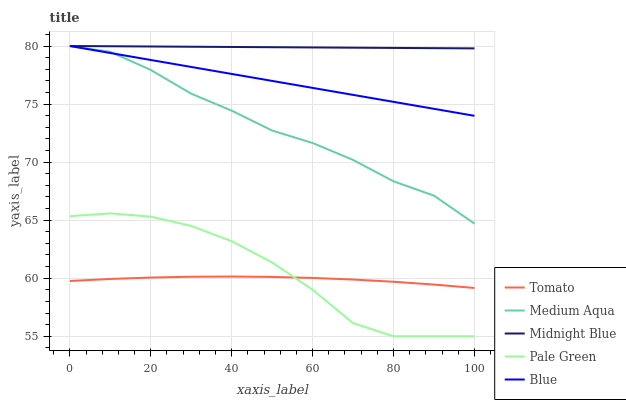Does Tomato have the minimum area under the curve?
Answer yes or no. Yes. Does Midnight Blue have the maximum area under the curve?
Answer yes or no. Yes. Does Blue have the minimum area under the curve?
Answer yes or no. No. Does Blue have the maximum area under the curve?
Answer yes or no. No. Is Midnight Blue the smoothest?
Answer yes or no. Yes. Is Pale Green the roughest?
Answer yes or no. Yes. Is Blue the smoothest?
Answer yes or no. No. Is Blue the roughest?
Answer yes or no. No. Does Pale Green have the lowest value?
Answer yes or no. Yes. Does Blue have the lowest value?
Answer yes or no. No. Does Midnight Blue have the highest value?
Answer yes or no. Yes. Does Pale Green have the highest value?
Answer yes or no. No. Is Pale Green less than Medium Aqua?
Answer yes or no. Yes. Is Blue greater than Tomato?
Answer yes or no. Yes. Does Blue intersect Midnight Blue?
Answer yes or no. Yes. Is Blue less than Midnight Blue?
Answer yes or no. No. Is Blue greater than Midnight Blue?
Answer yes or no. No. Does Pale Green intersect Medium Aqua?
Answer yes or no. No. 